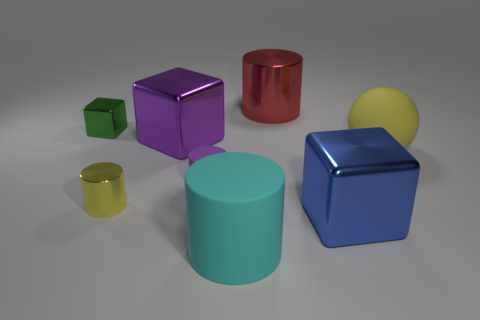Subtract all brown cylinders. Subtract all yellow balls. How many cylinders are left? 4 Add 2 tiny gray metallic blocks. How many objects exist? 10 Subtract all cubes. How many objects are left? 5 Add 4 big red things. How many big red things are left? 5 Add 4 blue cubes. How many blue cubes exist? 5 Subtract 0 cyan balls. How many objects are left? 8 Subtract all big red matte objects. Subtract all tiny green objects. How many objects are left? 7 